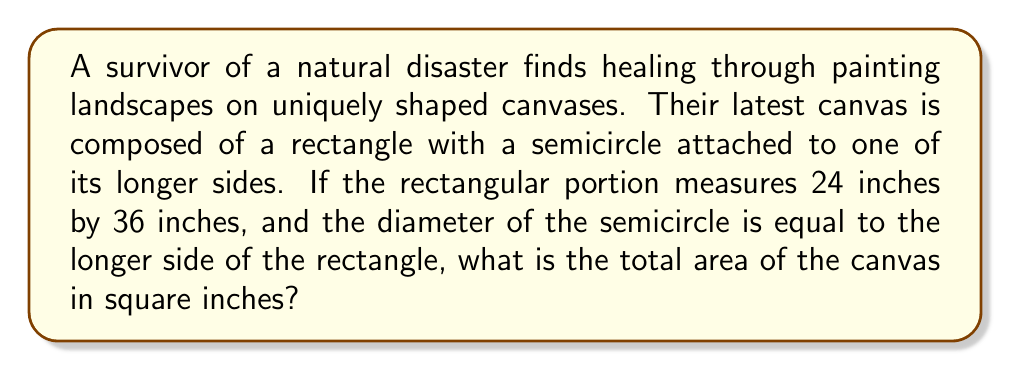Give your solution to this math problem. Let's approach this step-by-step:

1) First, calculate the area of the rectangular portion:
   $A_{rectangle} = length \times width$
   $A_{rectangle} = 36 \times 24 = 864$ square inches

2) Now, for the semicircle:
   The diameter is equal to the longer side of the rectangle, which is 36 inches.
   The radius is half of this: $r = 36 \div 2 = 18$ inches

3) The area of a full circle is $\pi r^2$, so the area of a semicircle is half of this:
   $$A_{semicircle} = \frac{1}{2} \pi r^2$$

4) Substituting the radius:
   $$A_{semicircle} = \frac{1}{2} \pi (18)^2 = 162\pi$$ square inches

5) The total area is the sum of the rectangle and semicircle areas:
   $$A_{total} = A_{rectangle} + A_{semicircle}$$
   $$A_{total} = 864 + 162\pi$$ square inches

6) If we want to approximate this with $\pi \approx 3.14159$:
   $A_{total} \approx 864 + 162(3.14159) \approx 1372.94$ square inches

[asy]
unitsize(0.1 inch);
fill((0,0)--(36,0)--(36,24)--(0,24)--cycle,gray(0.9));
fill(arc((18,24),18,0,180)--cycle,gray(0.9));
draw((0,0)--(36,0)--(36,24)--(0,24)--cycle);
draw(arc((18,24),18,0,180));
label("36",(18,0),S);
label("24",(0,12),W);
label("r=18",(27,24),NE);
[/asy]
Answer: $864 + 162\pi$ sq in 